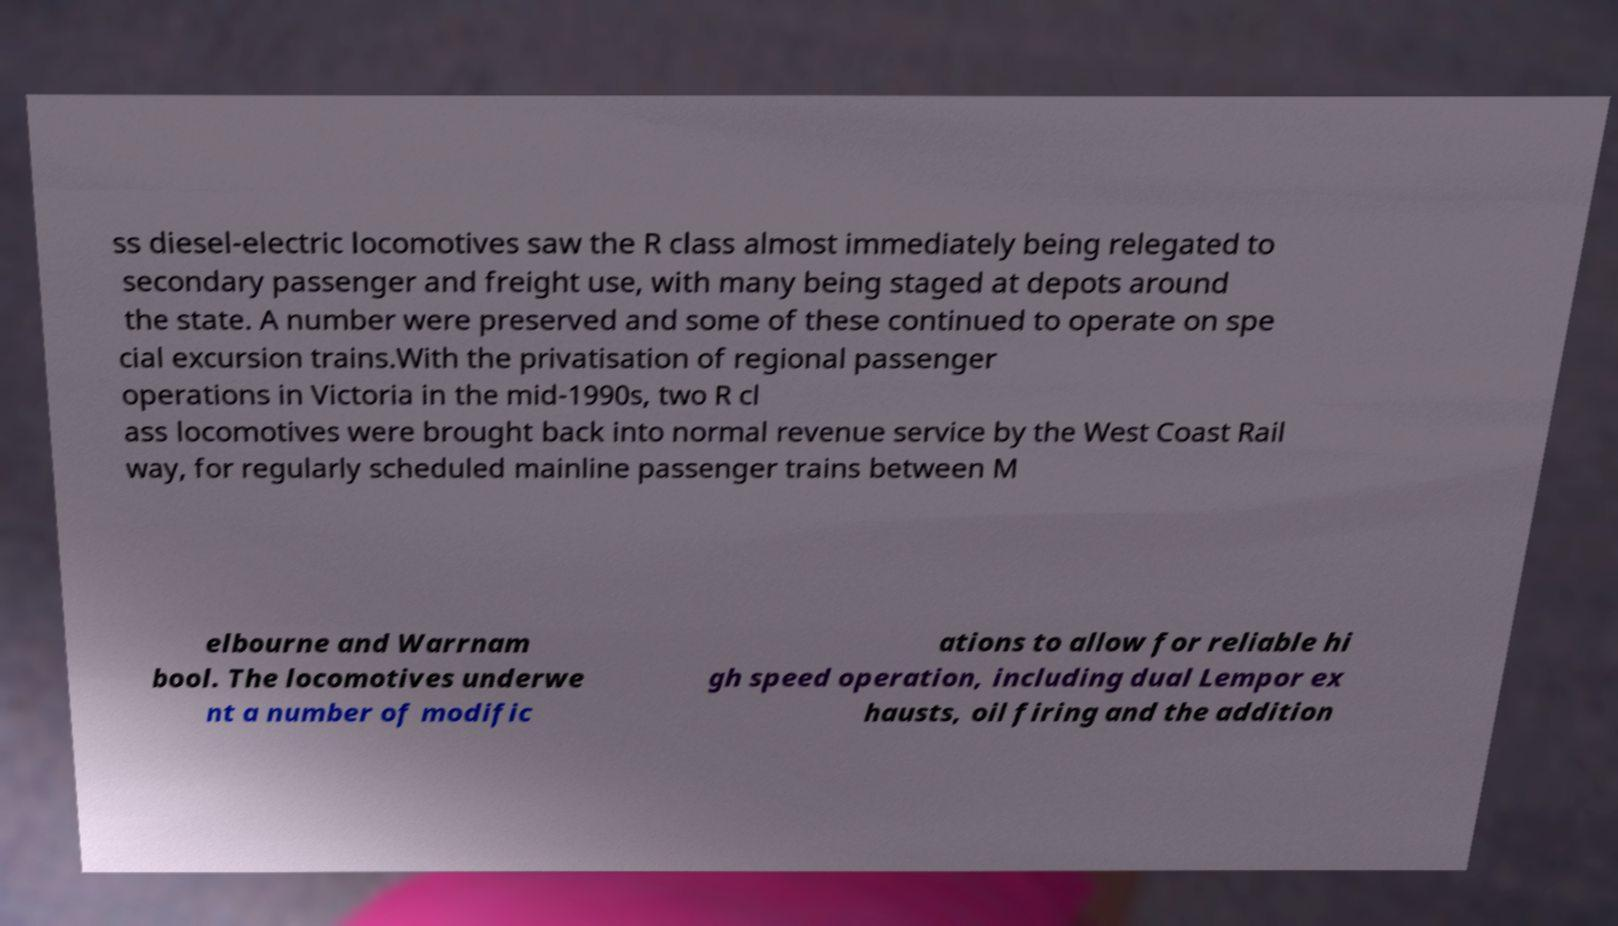Can you accurately transcribe the text from the provided image for me? ss diesel-electric locomotives saw the R class almost immediately being relegated to secondary passenger and freight use, with many being staged at depots around the state. A number were preserved and some of these continued to operate on spe cial excursion trains.With the privatisation of regional passenger operations in Victoria in the mid-1990s, two R cl ass locomotives were brought back into normal revenue service by the West Coast Rail way, for regularly scheduled mainline passenger trains between M elbourne and Warrnam bool. The locomotives underwe nt a number of modific ations to allow for reliable hi gh speed operation, including dual Lempor ex hausts, oil firing and the addition 